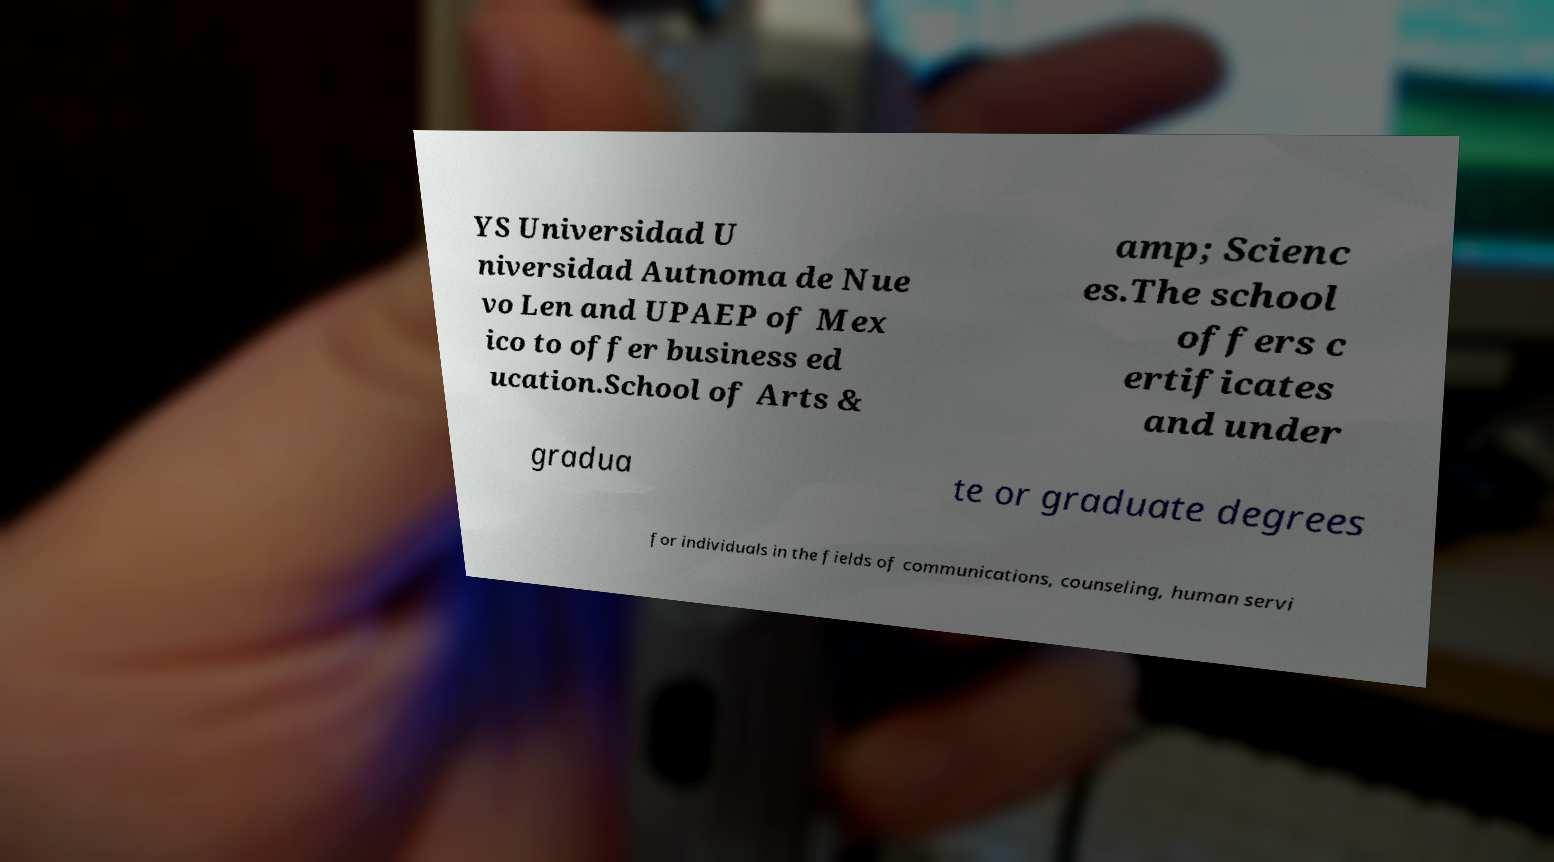What messages or text are displayed in this image? I need them in a readable, typed format. YS Universidad U niversidad Autnoma de Nue vo Len and UPAEP of Mex ico to offer business ed ucation.School of Arts & amp; Scienc es.The school offers c ertificates and under gradua te or graduate degrees for individuals in the fields of communications, counseling, human servi 